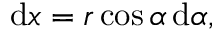Convert formula to latex. <formula><loc_0><loc_0><loc_500><loc_500>d x = r \cos \alpha \, d \alpha ,</formula> 